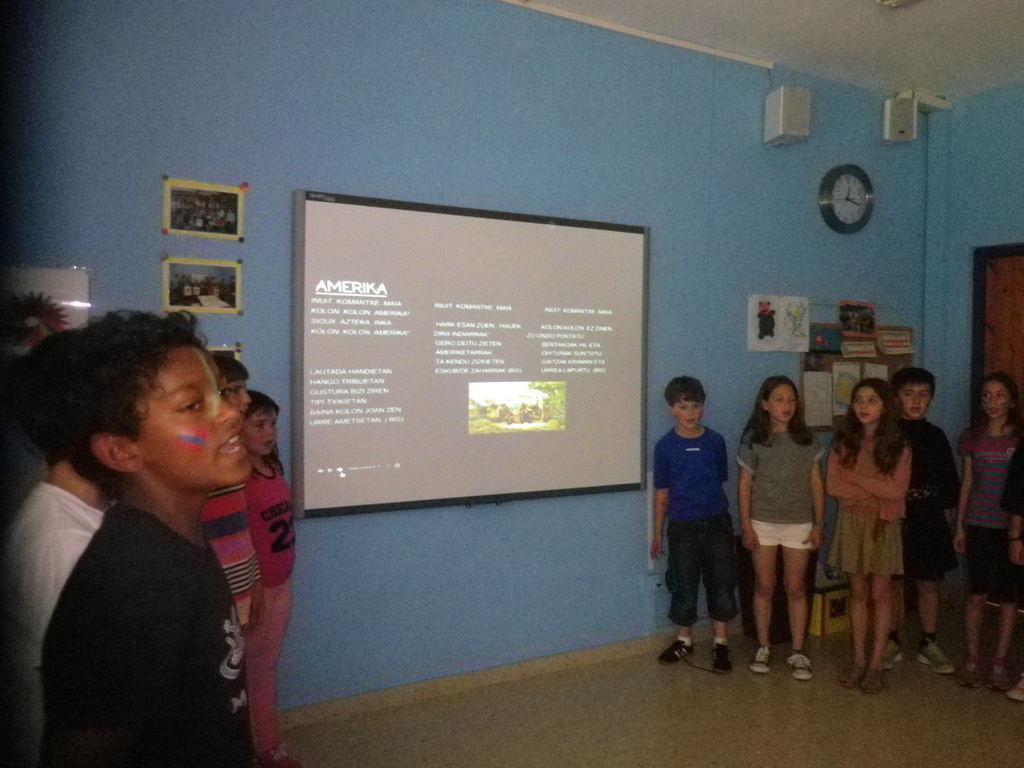In one or two sentences, can you explain what this image depicts? In this image there are a few kids standing, beside them on the wall there is a screen and photo frames, wall clocks, speakers and some other objects, behind them on the floor there are some objects and there is a closed door. 